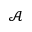<formula> <loc_0><loc_0><loc_500><loc_500>\mathcal { A }</formula> 